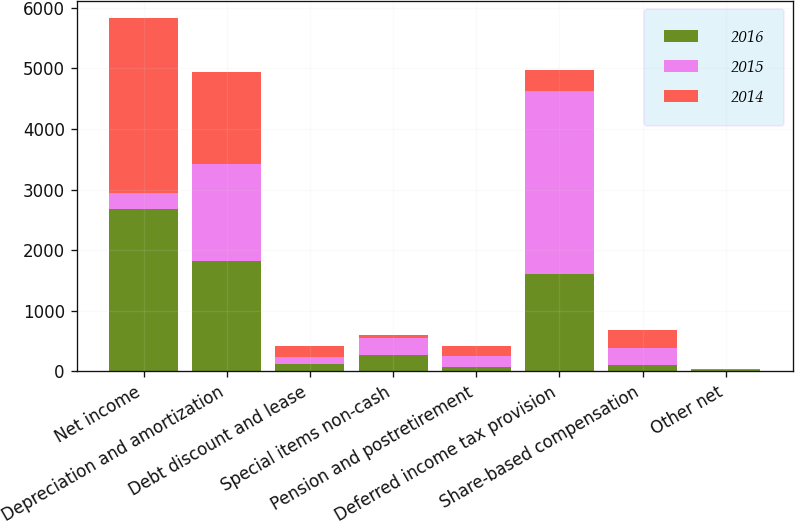Convert chart to OTSL. <chart><loc_0><loc_0><loc_500><loc_500><stacked_bar_chart><ecel><fcel>Net income<fcel>Depreciation and amortization<fcel>Debt discount and lease<fcel>Special items non-cash<fcel>Pension and postretirement<fcel>Deferred income tax provision<fcel>Share-based compensation<fcel>Other net<nl><fcel>2016<fcel>2676<fcel>1818<fcel>119<fcel>270<fcel>68<fcel>1611<fcel>100<fcel>18<nl><fcel>2015<fcel>270<fcel>1609<fcel>122<fcel>273<fcel>193<fcel>3014<fcel>284<fcel>12<nl><fcel>2014<fcel>2882<fcel>1513<fcel>171<fcel>52<fcel>163<fcel>346<fcel>304<fcel>3<nl></chart> 